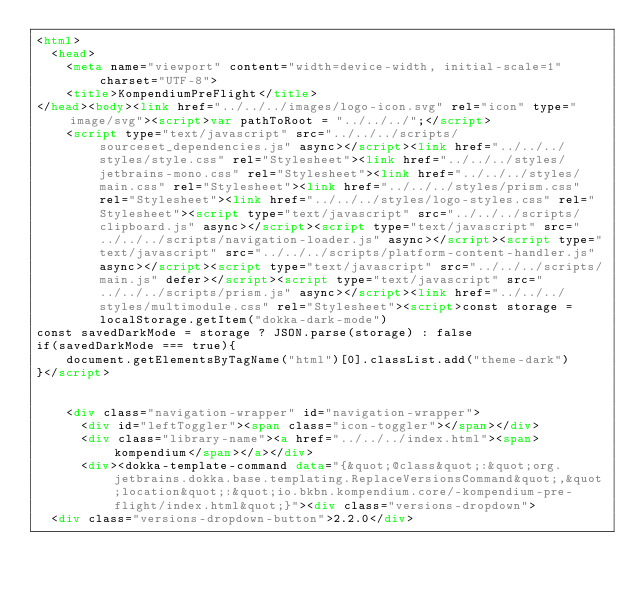Convert code to text. <code><loc_0><loc_0><loc_500><loc_500><_HTML_><html>
  <head>
    <meta name="viewport" content="width=device-width, initial-scale=1" charset="UTF-8">
    <title>KompendiumPreFlight</title>
</head><body><link href="../../../images/logo-icon.svg" rel="icon" type="image/svg"><script>var pathToRoot = "../../../";</script>
    <script type="text/javascript" src="../../../scripts/sourceset_dependencies.js" async></script><link href="../../../styles/style.css" rel="Stylesheet"><link href="../../../styles/jetbrains-mono.css" rel="Stylesheet"><link href="../../../styles/main.css" rel="Stylesheet"><link href="../../../styles/prism.css" rel="Stylesheet"><link href="../../../styles/logo-styles.css" rel="Stylesheet"><script type="text/javascript" src="../../../scripts/clipboard.js" async></script><script type="text/javascript" src="../../../scripts/navigation-loader.js" async></script><script type="text/javascript" src="../../../scripts/platform-content-handler.js" async></script><script type="text/javascript" src="../../../scripts/main.js" defer></script><script type="text/javascript" src="../../../scripts/prism.js" async></script><link href="../../../styles/multimodule.css" rel="Stylesheet"><script>const storage = localStorage.getItem("dokka-dark-mode")
const savedDarkMode = storage ? JSON.parse(storage) : false
if(savedDarkMode === true){
    document.getElementsByTagName("html")[0].classList.add("theme-dark")
}</script>

  
    <div class="navigation-wrapper" id="navigation-wrapper">
      <div id="leftToggler"><span class="icon-toggler"></span></div>
      <div class="library-name"><a href="../../../index.html"><span>kompendium</span></a></div>
      <div><dokka-template-command data="{&quot;@class&quot;:&quot;org.jetbrains.dokka.base.templating.ReplaceVersionsCommand&quot;,&quot;location&quot;:&quot;io.bkbn.kompendium.core/-kompendium-pre-flight/index.html&quot;}"><div class="versions-dropdown">
  <div class="versions-dropdown-button">2.2.0</div></code> 